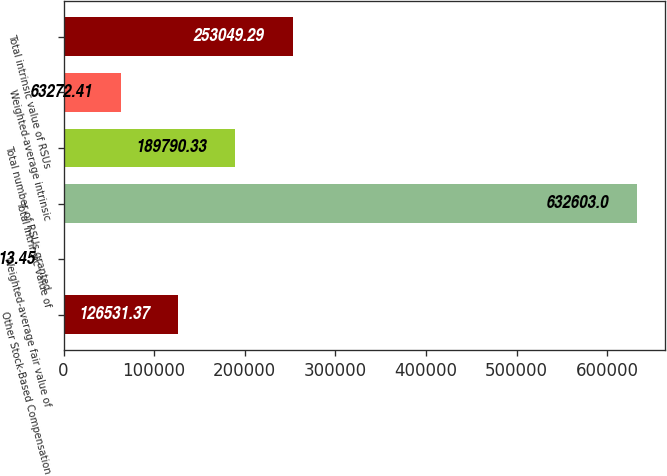Convert chart. <chart><loc_0><loc_0><loc_500><loc_500><bar_chart><fcel>Other Stock-Based Compensation<fcel>Weighted-average fair value of<fcel>Total intrinsic value of<fcel>Total number of RSUs granted<fcel>Weighted-average intrinsic<fcel>Total intrinsic value of RSUs<nl><fcel>126531<fcel>13.45<fcel>632603<fcel>189790<fcel>63272.4<fcel>253049<nl></chart> 